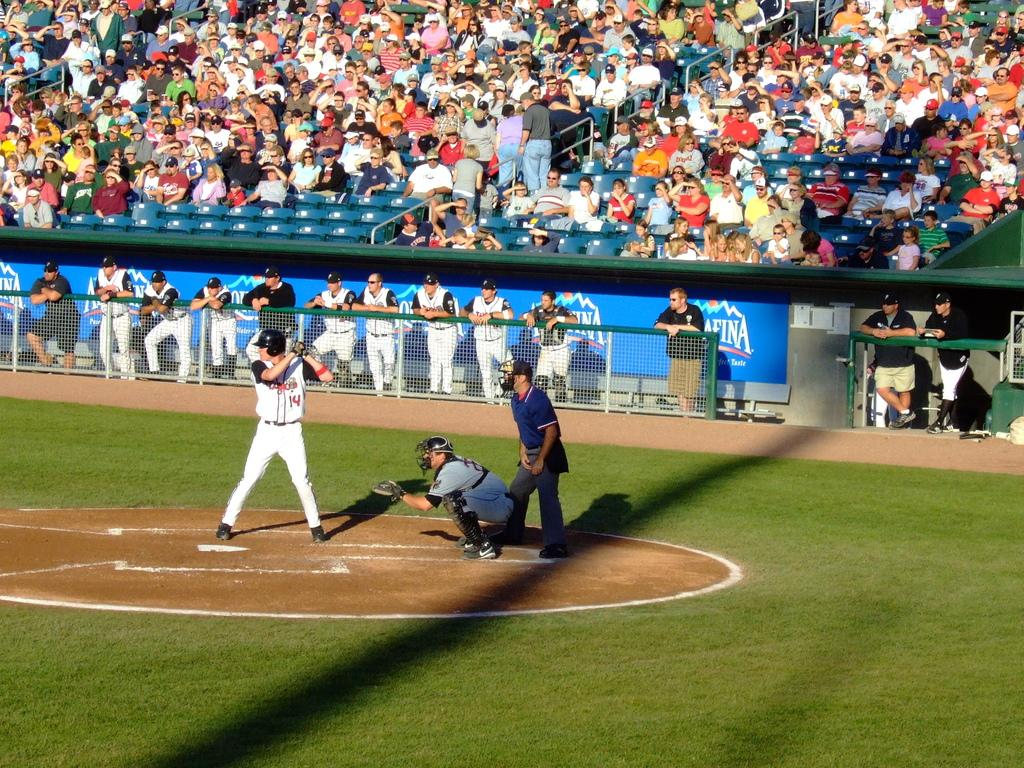<image>
Summarize the visual content of the image. a player with the number 14 on the jersey 